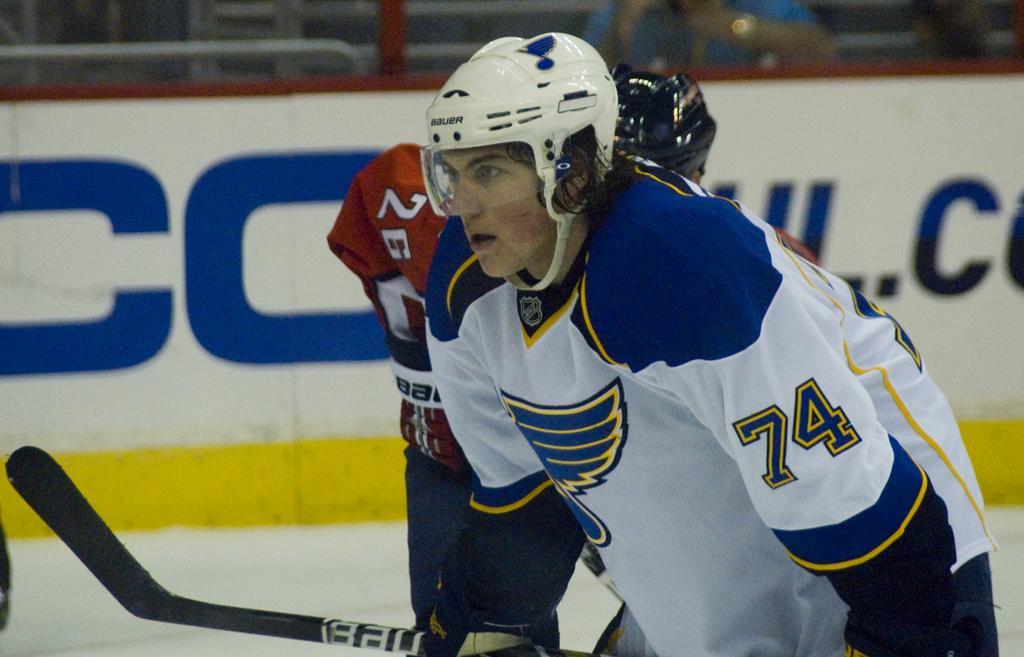In one or two sentences, can you explain what this image depicts? In this picture we can see a stick and two people wore helmets. In the background we can see a poster, some objects and it is blurry. 